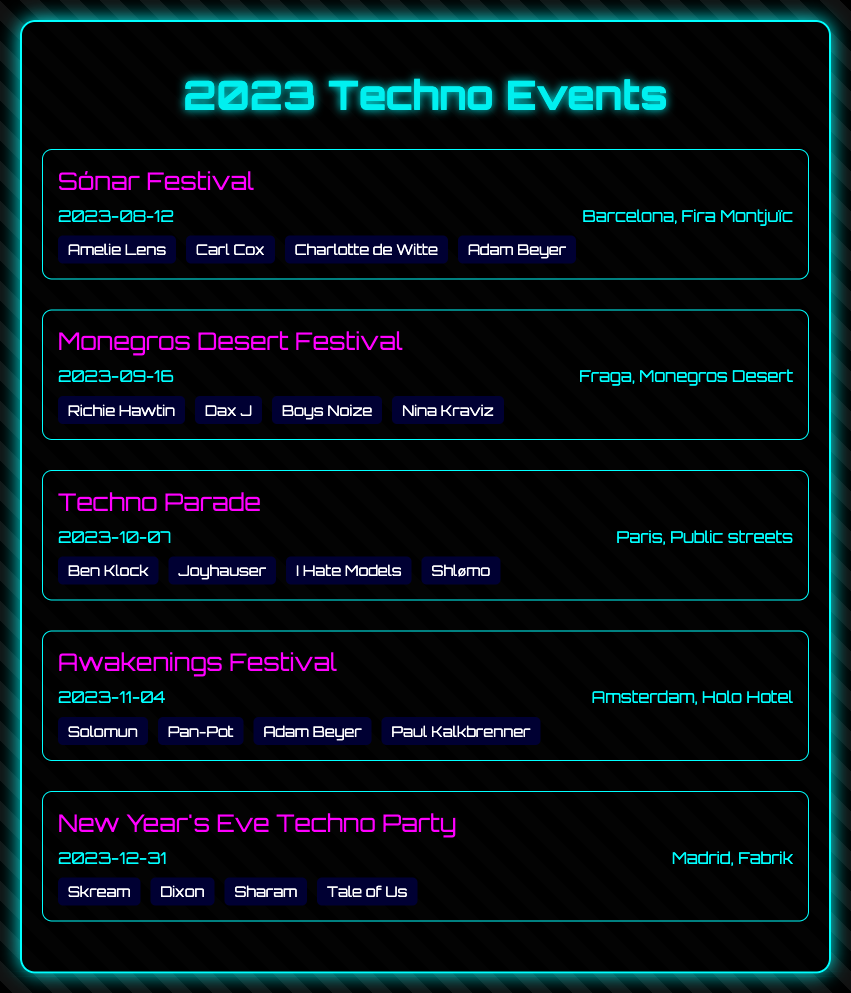What is the event name on August 12? The event happening on August 12 is Sónar Festival.
Answer: Sónar Festival Where is the Monegros Desert Festival located? The Monegros Desert Festival takes place in Fraga, Monegros Desert.
Answer: Monegros Desert Who is performing at the Techno Parade? The lineup for the Techno Parade includes Ben Klock, Joyhauser, I Hate Models, Shlømo.
Answer: Ben Klock, Joyhauser, I Hate Models, Shlømo What city will host the New Year's Eve Techno Party? The New Year's Eve Techno Party will be held in Madrid.
Answer: Madrid How many artists are listed for the Awakenings Festival? The Awakenings Festival has four artists listed in its lineup.
Answer: Four Which event features Adam Beyer? Adam Beyer is featured in both Sónar Festival and Awakenings Festival.
Answer: Sónar Festival, Awakenings Festival What is the date of the last event in 2023? The last event in 2023 is scheduled for December 31.
Answer: December 31 What venue is associated with the Awakenings Festival? The venue for the Awakenings Festival is Holo Hotel.
Answer: Holo Hotel Who is one of the artists performing at the New Year's Eve Techno Party? One of the artists performing at the New Year's Eve Techno Party is Skream.
Answer: Skream 